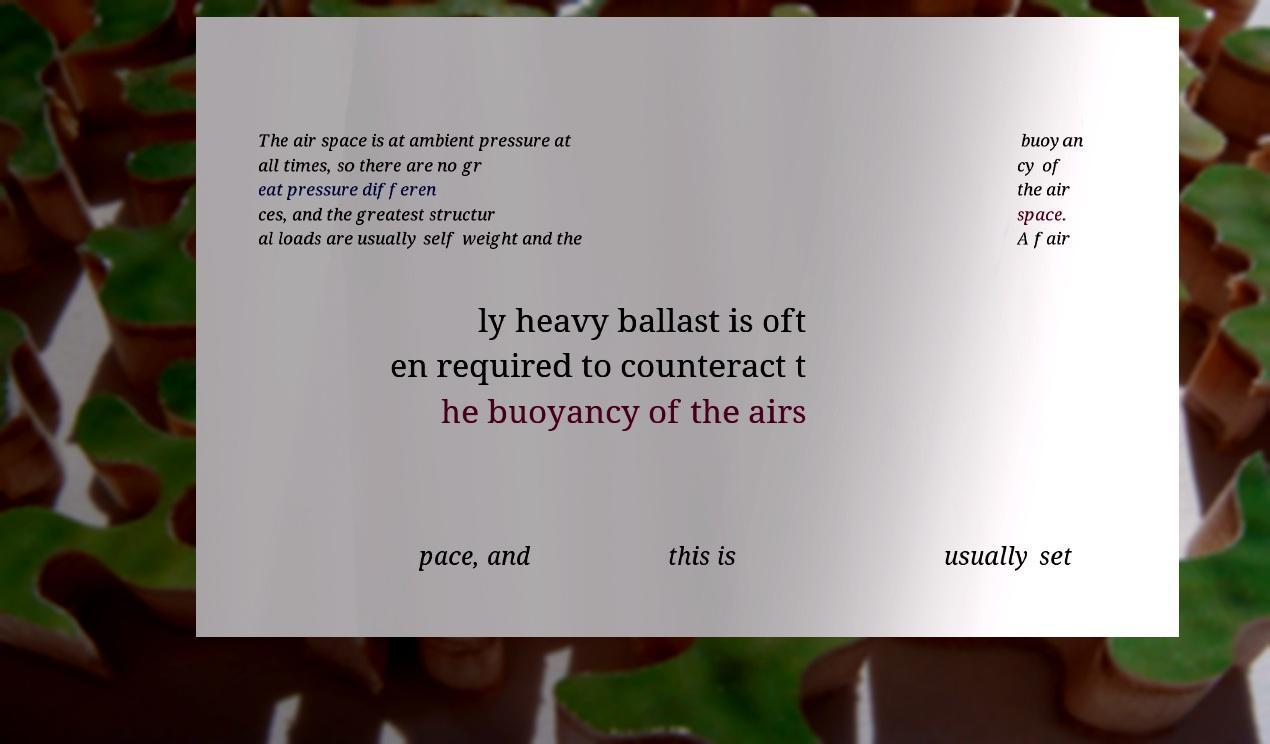Please identify and transcribe the text found in this image. The air space is at ambient pressure at all times, so there are no gr eat pressure differen ces, and the greatest structur al loads are usually self weight and the buoyan cy of the air space. A fair ly heavy ballast is oft en required to counteract t he buoyancy of the airs pace, and this is usually set 